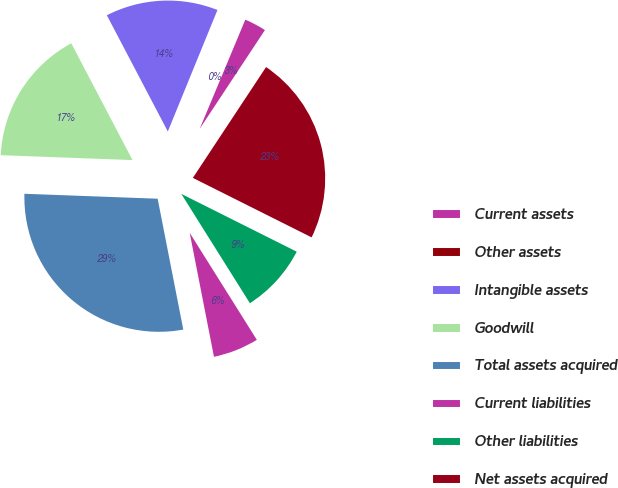<chart> <loc_0><loc_0><loc_500><loc_500><pie_chart><fcel>Current assets<fcel>Other assets<fcel>Intangible assets<fcel>Goodwill<fcel>Total assets acquired<fcel>Current liabilities<fcel>Other liabilities<fcel>Net assets acquired<nl><fcel>2.99%<fcel>0.13%<fcel>13.86%<fcel>16.72%<fcel>28.67%<fcel>5.84%<fcel>8.69%<fcel>23.1%<nl></chart> 